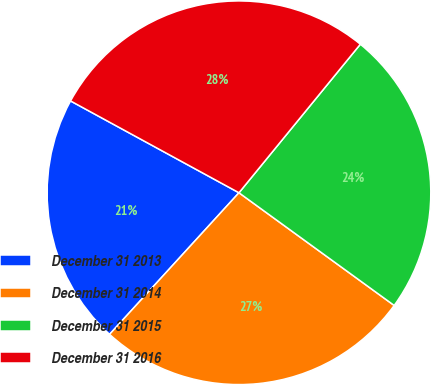<chart> <loc_0><loc_0><loc_500><loc_500><pie_chart><fcel>December 31 2013<fcel>December 31 2014<fcel>December 31 2015<fcel>December 31 2016<nl><fcel>21.16%<fcel>26.79%<fcel>24.09%<fcel>27.96%<nl></chart> 